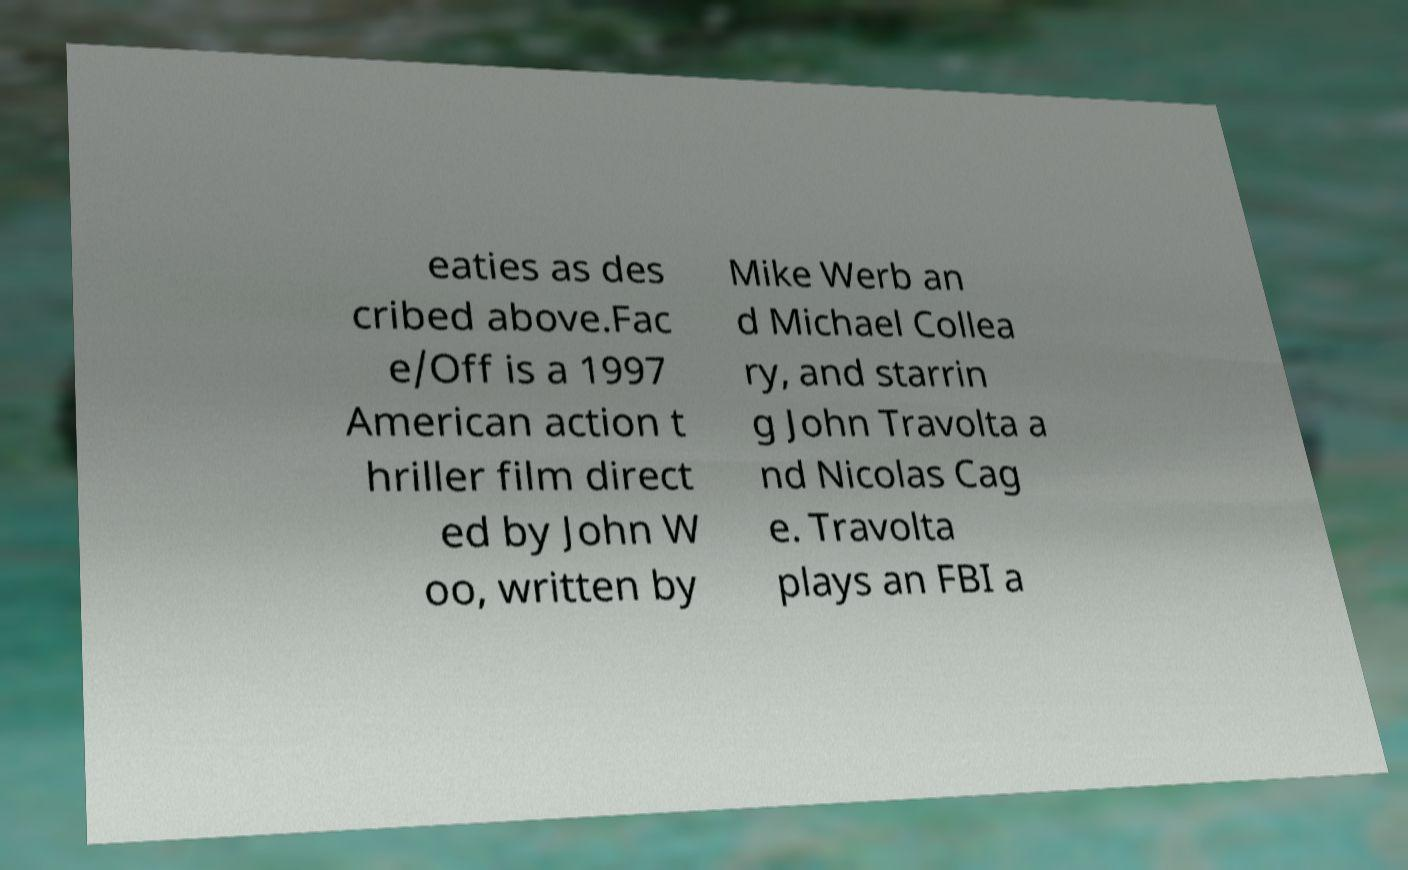Can you accurately transcribe the text from the provided image for me? eaties as des cribed above.Fac e/Off is a 1997 American action t hriller film direct ed by John W oo, written by Mike Werb an d Michael Collea ry, and starrin g John Travolta a nd Nicolas Cag e. Travolta plays an FBI a 